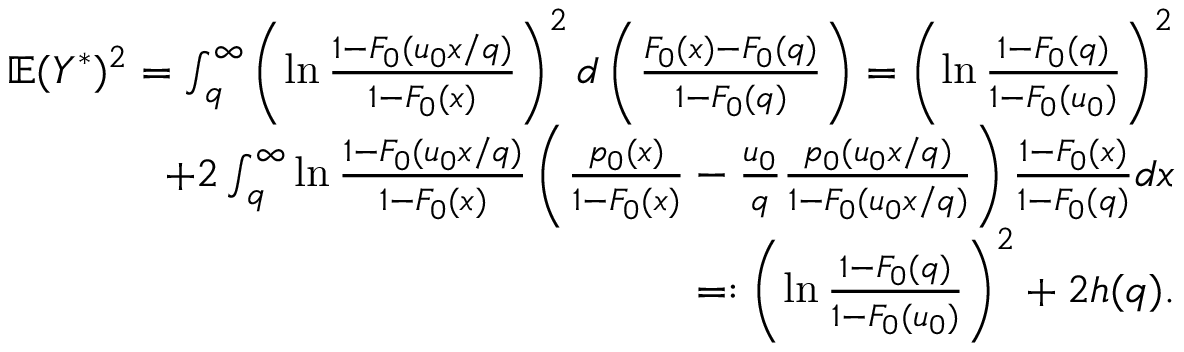<formula> <loc_0><loc_0><loc_500><loc_500>\begin{array} { r } { \mathbb { E } ( Y ^ { \ast } ) ^ { 2 } = \int _ { q } ^ { \infty } \left ( \ln \frac { 1 - F _ { 0 } ( u _ { 0 } x / q ) } { 1 - F _ { 0 } ( x ) } \right ) ^ { 2 } d \left ( \frac { F _ { 0 } ( x ) - F _ { 0 } ( q ) } { 1 - F _ { 0 } ( q ) } \right ) = \left ( \ln \frac { 1 - F _ { 0 } ( q ) } { 1 - F _ { 0 } ( u _ { 0 } ) } \right ) ^ { 2 } } \\ { + 2 \int _ { q } ^ { \infty } \ln \frac { 1 - F _ { 0 } ( u _ { 0 } x / q ) } { 1 - F _ { 0 } ( x ) } \left ( \frac { p _ { 0 } ( x ) } { 1 - F _ { 0 } ( x ) } - \frac { u _ { 0 } } { q } \frac { p _ { 0 } ( u _ { 0 } x / q ) } { 1 - F _ { 0 } ( u _ { 0 } x / q ) } \right ) \frac { 1 - F _ { 0 } ( x ) } { 1 - F _ { 0 } ( q ) } d x } \\ { = \colon \left ( \ln \frac { 1 - F _ { 0 } ( q ) } { 1 - F _ { 0 } ( u _ { 0 } ) } \right ) ^ { 2 } + 2 h ( q ) . } \end{array}</formula> 